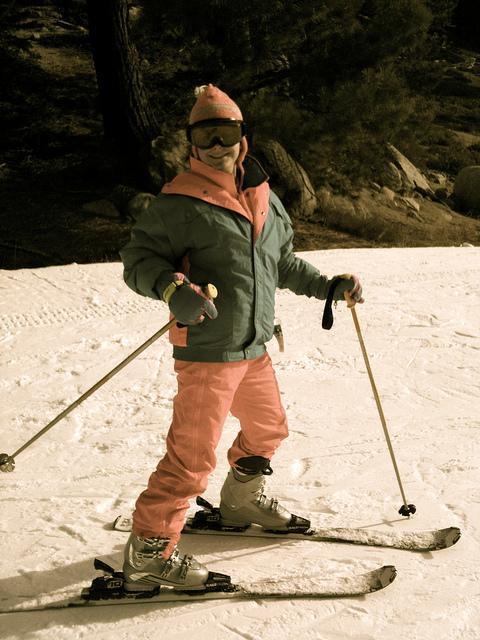How many ski are visible?
Give a very brief answer. 2. How many people are standing between the elephant trunks?
Give a very brief answer. 0. 